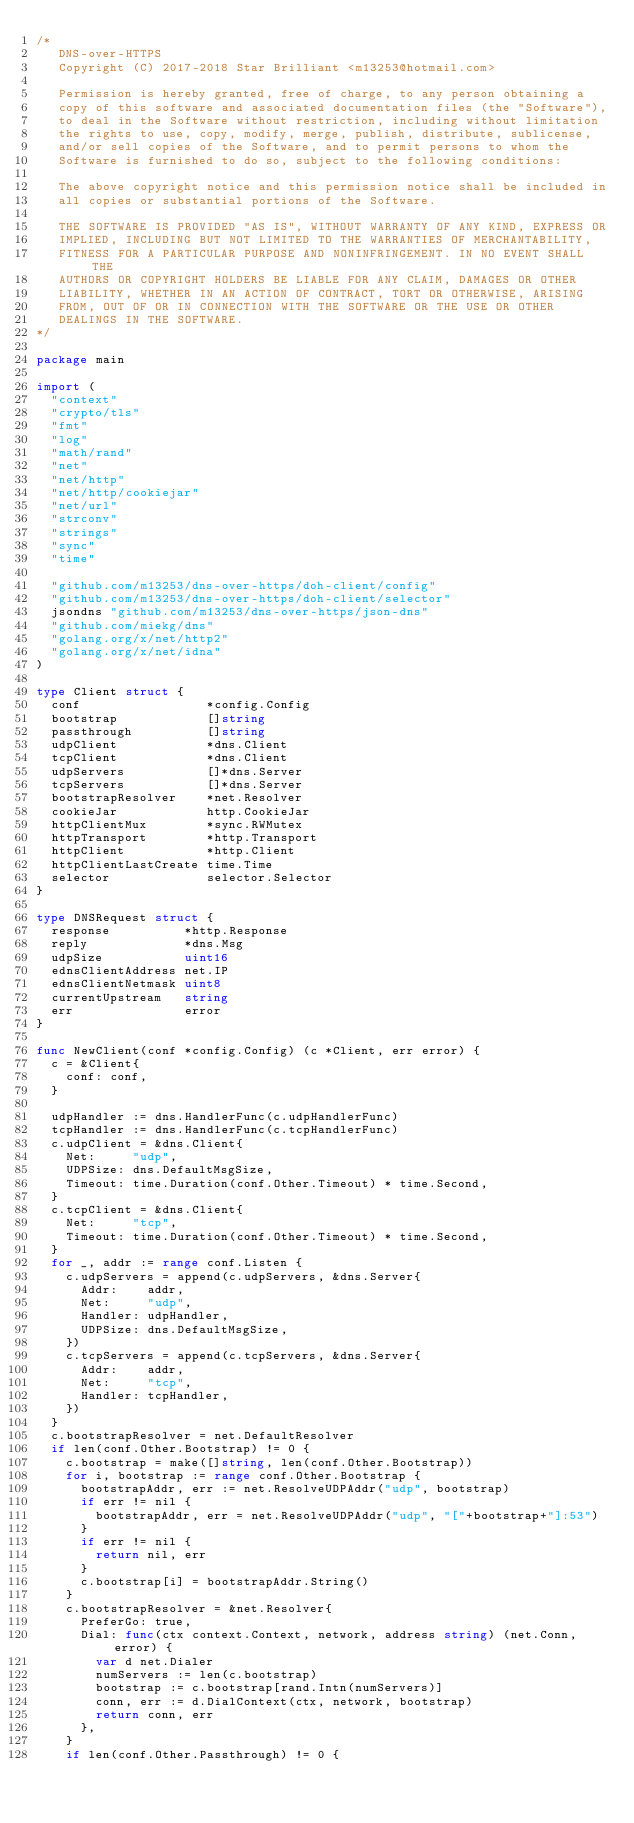Convert code to text. <code><loc_0><loc_0><loc_500><loc_500><_Go_>/*
   DNS-over-HTTPS
   Copyright (C) 2017-2018 Star Brilliant <m13253@hotmail.com>

   Permission is hereby granted, free of charge, to any person obtaining a
   copy of this software and associated documentation files (the "Software"),
   to deal in the Software without restriction, including without limitation
   the rights to use, copy, modify, merge, publish, distribute, sublicense,
   and/or sell copies of the Software, and to permit persons to whom the
   Software is furnished to do so, subject to the following conditions:

   The above copyright notice and this permission notice shall be included in
   all copies or substantial portions of the Software.

   THE SOFTWARE IS PROVIDED "AS IS", WITHOUT WARRANTY OF ANY KIND, EXPRESS OR
   IMPLIED, INCLUDING BUT NOT LIMITED TO THE WARRANTIES OF MERCHANTABILITY,
   FITNESS FOR A PARTICULAR PURPOSE AND NONINFRINGEMENT. IN NO EVENT SHALL THE
   AUTHORS OR COPYRIGHT HOLDERS BE LIABLE FOR ANY CLAIM, DAMAGES OR OTHER
   LIABILITY, WHETHER IN AN ACTION OF CONTRACT, TORT OR OTHERWISE, ARISING
   FROM, OUT OF OR IN CONNECTION WITH THE SOFTWARE OR THE USE OR OTHER
   DEALINGS IN THE SOFTWARE.
*/

package main

import (
	"context"
	"crypto/tls"
	"fmt"
	"log"
	"math/rand"
	"net"
	"net/http"
	"net/http/cookiejar"
	"net/url"
	"strconv"
	"strings"
	"sync"
	"time"

	"github.com/m13253/dns-over-https/doh-client/config"
	"github.com/m13253/dns-over-https/doh-client/selector"
	jsondns "github.com/m13253/dns-over-https/json-dns"
	"github.com/miekg/dns"
	"golang.org/x/net/http2"
	"golang.org/x/net/idna"
)

type Client struct {
	conf                 *config.Config
	bootstrap            []string
	passthrough          []string
	udpClient            *dns.Client
	tcpClient            *dns.Client
	udpServers           []*dns.Server
	tcpServers           []*dns.Server
	bootstrapResolver    *net.Resolver
	cookieJar            http.CookieJar
	httpClientMux        *sync.RWMutex
	httpTransport        *http.Transport
	httpClient           *http.Client
	httpClientLastCreate time.Time
	selector             selector.Selector
}

type DNSRequest struct {
	response          *http.Response
	reply             *dns.Msg
	udpSize           uint16
	ednsClientAddress net.IP
	ednsClientNetmask uint8
	currentUpstream   string
	err               error
}

func NewClient(conf *config.Config) (c *Client, err error) {
	c = &Client{
		conf: conf,
	}

	udpHandler := dns.HandlerFunc(c.udpHandlerFunc)
	tcpHandler := dns.HandlerFunc(c.tcpHandlerFunc)
	c.udpClient = &dns.Client{
		Net:     "udp",
		UDPSize: dns.DefaultMsgSize,
		Timeout: time.Duration(conf.Other.Timeout) * time.Second,
	}
	c.tcpClient = &dns.Client{
		Net:     "tcp",
		Timeout: time.Duration(conf.Other.Timeout) * time.Second,
	}
	for _, addr := range conf.Listen {
		c.udpServers = append(c.udpServers, &dns.Server{
			Addr:    addr,
			Net:     "udp",
			Handler: udpHandler,
			UDPSize: dns.DefaultMsgSize,
		})
		c.tcpServers = append(c.tcpServers, &dns.Server{
			Addr:    addr,
			Net:     "tcp",
			Handler: tcpHandler,
		})
	}
	c.bootstrapResolver = net.DefaultResolver
	if len(conf.Other.Bootstrap) != 0 {
		c.bootstrap = make([]string, len(conf.Other.Bootstrap))
		for i, bootstrap := range conf.Other.Bootstrap {
			bootstrapAddr, err := net.ResolveUDPAddr("udp", bootstrap)
			if err != nil {
				bootstrapAddr, err = net.ResolveUDPAddr("udp", "["+bootstrap+"]:53")
			}
			if err != nil {
				return nil, err
			}
			c.bootstrap[i] = bootstrapAddr.String()
		}
		c.bootstrapResolver = &net.Resolver{
			PreferGo: true,
			Dial: func(ctx context.Context, network, address string) (net.Conn, error) {
				var d net.Dialer
				numServers := len(c.bootstrap)
				bootstrap := c.bootstrap[rand.Intn(numServers)]
				conn, err := d.DialContext(ctx, network, bootstrap)
				return conn, err
			},
		}
		if len(conf.Other.Passthrough) != 0 {</code> 